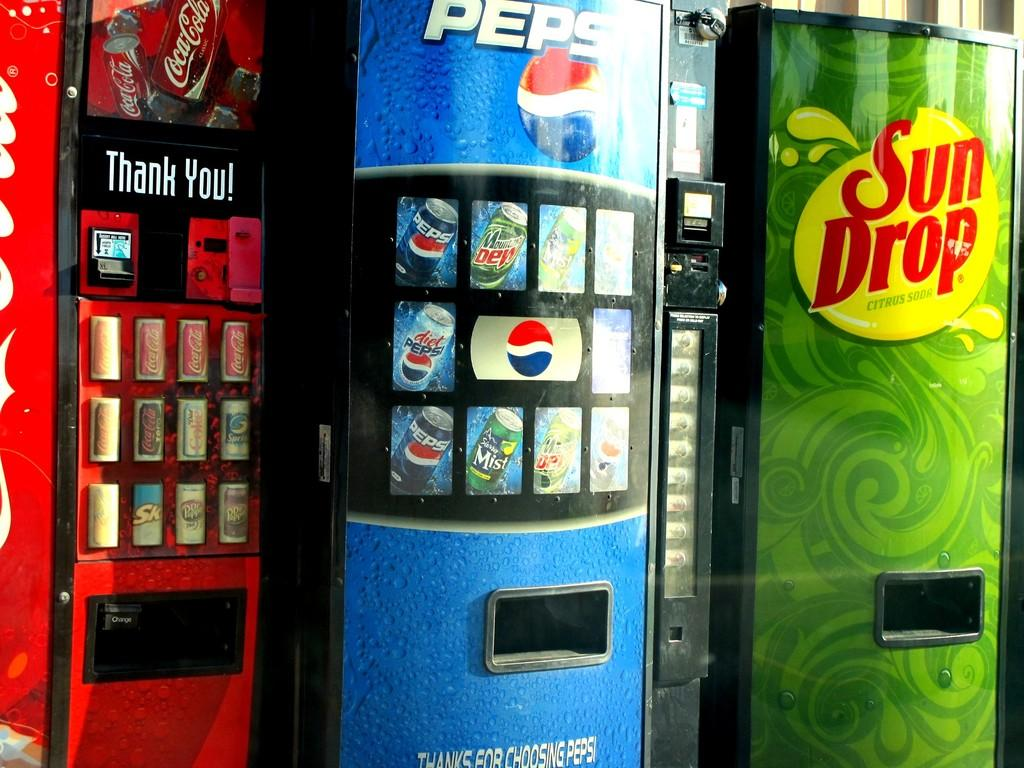<image>
Provide a brief description of the given image. Three beverage vending machines are side by side, Coke, Pepsi and Sun Drop. 